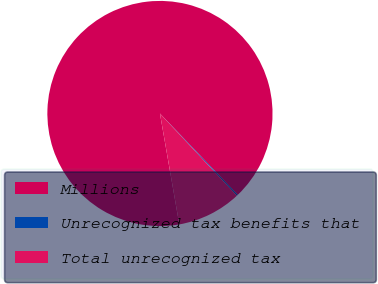Convert chart to OTSL. <chart><loc_0><loc_0><loc_500><loc_500><pie_chart><fcel>Millions<fcel>Unrecognized tax benefits that<fcel>Total unrecognized tax<nl><fcel>90.6%<fcel>0.18%<fcel>9.22%<nl></chart> 